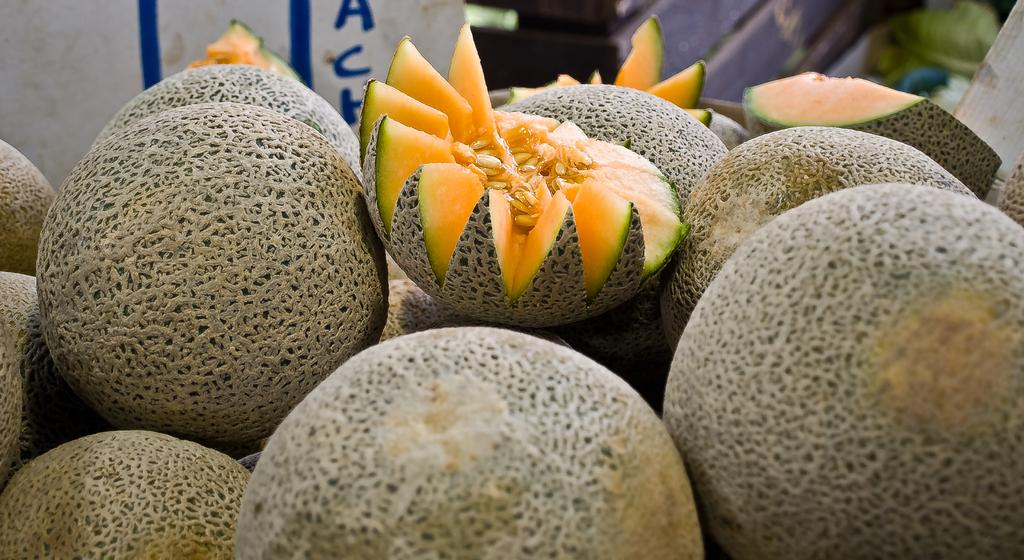What type of fruit is in the foreground of the image? There are honeydews in the foreground of the image. How are the honeydews presented in the image? There are cut pieces of honeydew in the foreground of the image. What can be seen in the background of the image? There is a whiteboard in the background of the image. What type of brush is used to clean the pollution in the image? There is no brush or pollution present in the image; it features honeydews and a whiteboard. 